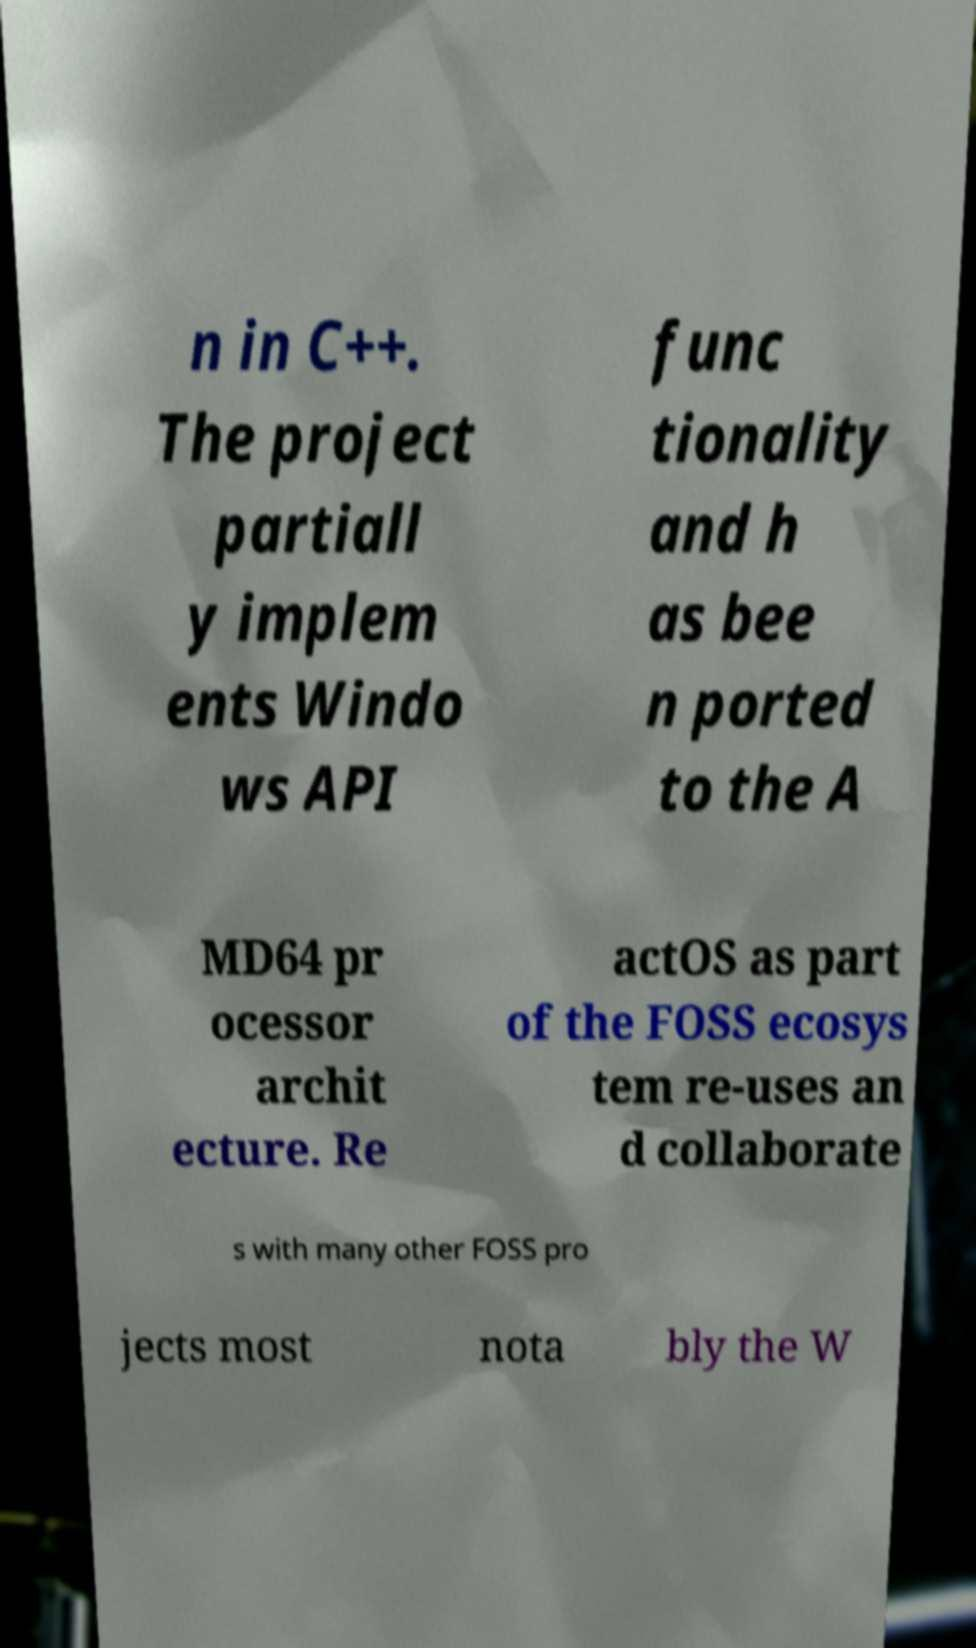What messages or text are displayed in this image? I need them in a readable, typed format. n in C++. The project partiall y implem ents Windo ws API func tionality and h as bee n ported to the A MD64 pr ocessor archit ecture. Re actOS as part of the FOSS ecosys tem re-uses an d collaborate s with many other FOSS pro jects most nota bly the W 